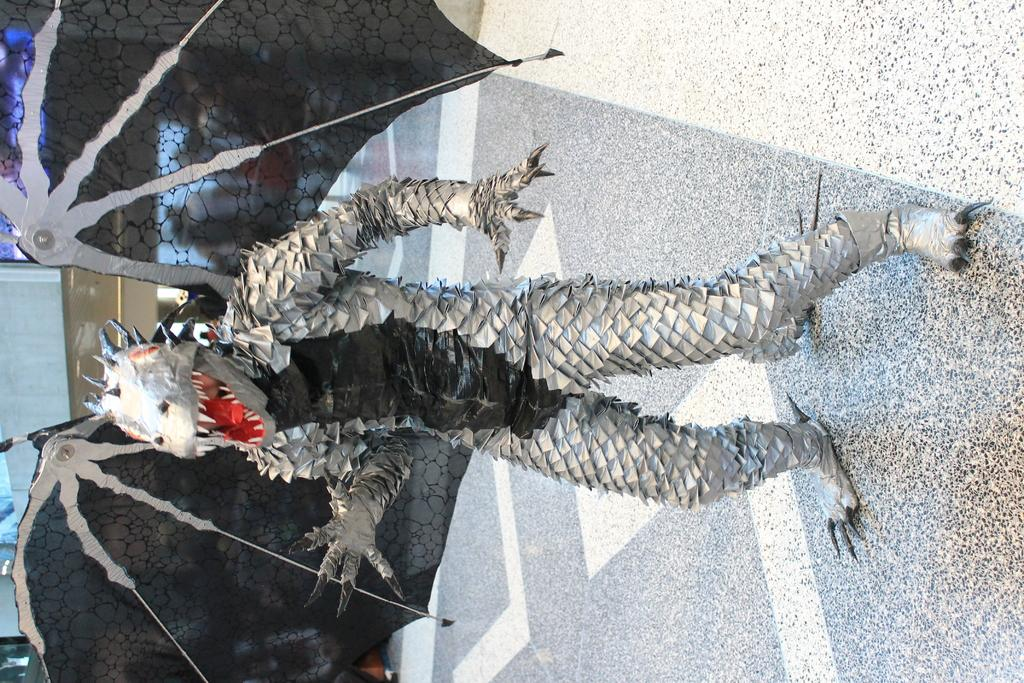What is present in the image? There is a person in the image. What is the person wearing? The person is wearing a black and white costume. What can be seen beneath the person in the image? The floor is visible in the image. How many books can be seen on the person's head in the image? There are no books visible on the person's head in the image. Is the person in the image a queen? There is no indication in the image that the person is a queen. 